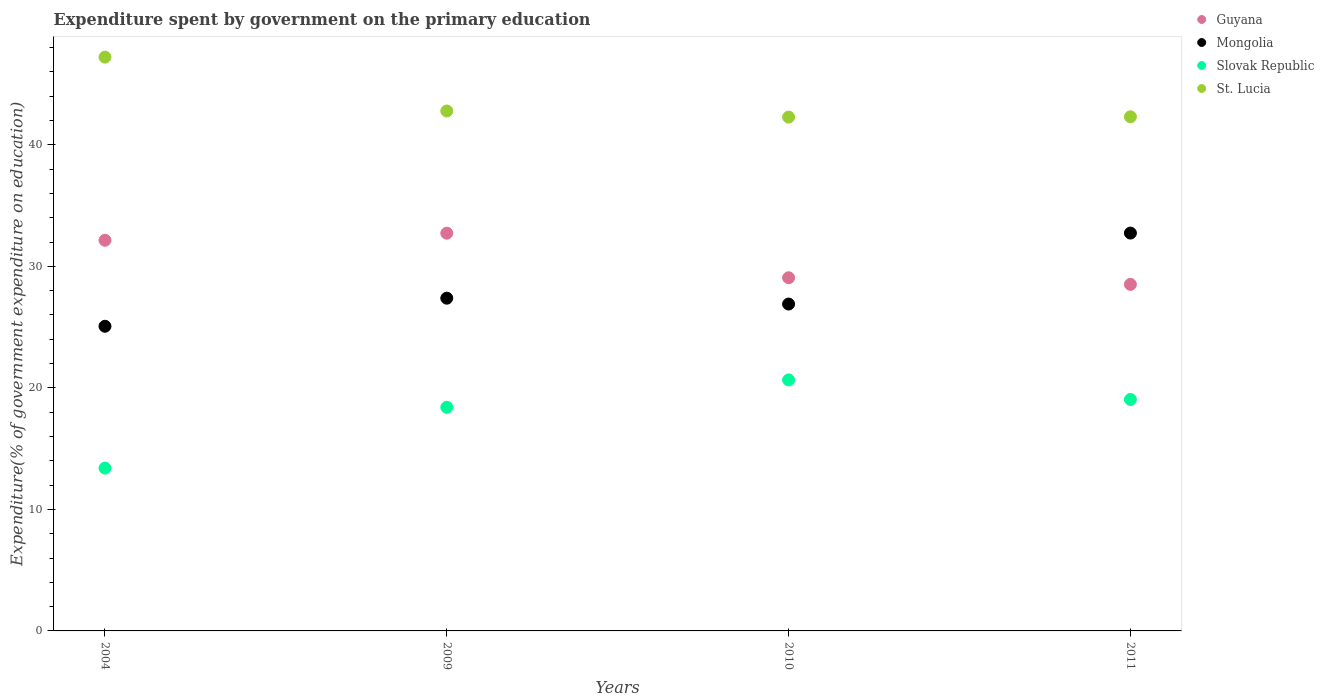How many different coloured dotlines are there?
Your answer should be compact. 4. What is the expenditure spent by government on the primary education in Mongolia in 2004?
Keep it short and to the point. 25.07. Across all years, what is the maximum expenditure spent by government on the primary education in Mongolia?
Offer a very short reply. 32.74. Across all years, what is the minimum expenditure spent by government on the primary education in Slovak Republic?
Provide a succinct answer. 13.4. In which year was the expenditure spent by government on the primary education in St. Lucia maximum?
Make the answer very short. 2004. What is the total expenditure spent by government on the primary education in Slovak Republic in the graph?
Your response must be concise. 71.5. What is the difference between the expenditure spent by government on the primary education in Mongolia in 2009 and that in 2011?
Ensure brevity in your answer.  -5.36. What is the difference between the expenditure spent by government on the primary education in Slovak Republic in 2004 and the expenditure spent by government on the primary education in St. Lucia in 2010?
Give a very brief answer. -28.88. What is the average expenditure spent by government on the primary education in Guyana per year?
Provide a short and direct response. 30.61. In the year 2009, what is the difference between the expenditure spent by government on the primary education in Guyana and expenditure spent by government on the primary education in Slovak Republic?
Offer a very short reply. 14.33. In how many years, is the expenditure spent by government on the primary education in St. Lucia greater than 16 %?
Your answer should be compact. 4. What is the ratio of the expenditure spent by government on the primary education in Mongolia in 2009 to that in 2011?
Make the answer very short. 0.84. Is the expenditure spent by government on the primary education in St. Lucia in 2009 less than that in 2010?
Provide a succinct answer. No. What is the difference between the highest and the second highest expenditure spent by government on the primary education in Slovak Republic?
Ensure brevity in your answer.  1.61. What is the difference between the highest and the lowest expenditure spent by government on the primary education in Mongolia?
Keep it short and to the point. 7.67. Is the sum of the expenditure spent by government on the primary education in St. Lucia in 2004 and 2010 greater than the maximum expenditure spent by government on the primary education in Mongolia across all years?
Offer a very short reply. Yes. Is it the case that in every year, the sum of the expenditure spent by government on the primary education in Slovak Republic and expenditure spent by government on the primary education in Guyana  is greater than the sum of expenditure spent by government on the primary education in St. Lucia and expenditure spent by government on the primary education in Mongolia?
Your response must be concise. Yes. How many dotlines are there?
Give a very brief answer. 4. Does the graph contain grids?
Ensure brevity in your answer.  No. Where does the legend appear in the graph?
Give a very brief answer. Top right. How are the legend labels stacked?
Give a very brief answer. Vertical. What is the title of the graph?
Ensure brevity in your answer.  Expenditure spent by government on the primary education. What is the label or title of the Y-axis?
Ensure brevity in your answer.  Expenditure(% of government expenditure on education). What is the Expenditure(% of government expenditure on education) of Guyana in 2004?
Give a very brief answer. 32.14. What is the Expenditure(% of government expenditure on education) of Mongolia in 2004?
Your answer should be compact. 25.07. What is the Expenditure(% of government expenditure on education) of Slovak Republic in 2004?
Your response must be concise. 13.4. What is the Expenditure(% of government expenditure on education) of St. Lucia in 2004?
Your answer should be compact. 47.21. What is the Expenditure(% of government expenditure on education) of Guyana in 2009?
Make the answer very short. 32.73. What is the Expenditure(% of government expenditure on education) in Mongolia in 2009?
Your response must be concise. 27.38. What is the Expenditure(% of government expenditure on education) of Slovak Republic in 2009?
Provide a short and direct response. 18.4. What is the Expenditure(% of government expenditure on education) of St. Lucia in 2009?
Your answer should be very brief. 42.78. What is the Expenditure(% of government expenditure on education) in Guyana in 2010?
Ensure brevity in your answer.  29.06. What is the Expenditure(% of government expenditure on education) in Mongolia in 2010?
Provide a short and direct response. 26.9. What is the Expenditure(% of government expenditure on education) in Slovak Republic in 2010?
Your answer should be very brief. 20.65. What is the Expenditure(% of government expenditure on education) of St. Lucia in 2010?
Make the answer very short. 42.28. What is the Expenditure(% of government expenditure on education) of Guyana in 2011?
Keep it short and to the point. 28.51. What is the Expenditure(% of government expenditure on education) of Mongolia in 2011?
Your answer should be compact. 32.74. What is the Expenditure(% of government expenditure on education) in Slovak Republic in 2011?
Provide a succinct answer. 19.05. What is the Expenditure(% of government expenditure on education) in St. Lucia in 2011?
Your answer should be very brief. 42.3. Across all years, what is the maximum Expenditure(% of government expenditure on education) in Guyana?
Ensure brevity in your answer.  32.73. Across all years, what is the maximum Expenditure(% of government expenditure on education) of Mongolia?
Provide a succinct answer. 32.74. Across all years, what is the maximum Expenditure(% of government expenditure on education) of Slovak Republic?
Your answer should be very brief. 20.65. Across all years, what is the maximum Expenditure(% of government expenditure on education) in St. Lucia?
Provide a succinct answer. 47.21. Across all years, what is the minimum Expenditure(% of government expenditure on education) of Guyana?
Your answer should be compact. 28.51. Across all years, what is the minimum Expenditure(% of government expenditure on education) of Mongolia?
Make the answer very short. 25.07. Across all years, what is the minimum Expenditure(% of government expenditure on education) of Slovak Republic?
Your answer should be very brief. 13.4. Across all years, what is the minimum Expenditure(% of government expenditure on education) of St. Lucia?
Offer a terse response. 42.28. What is the total Expenditure(% of government expenditure on education) in Guyana in the graph?
Offer a very short reply. 122.45. What is the total Expenditure(% of government expenditure on education) of Mongolia in the graph?
Make the answer very short. 112.08. What is the total Expenditure(% of government expenditure on education) in Slovak Republic in the graph?
Provide a short and direct response. 71.5. What is the total Expenditure(% of government expenditure on education) in St. Lucia in the graph?
Your response must be concise. 174.58. What is the difference between the Expenditure(% of government expenditure on education) of Guyana in 2004 and that in 2009?
Keep it short and to the point. -0.58. What is the difference between the Expenditure(% of government expenditure on education) in Mongolia in 2004 and that in 2009?
Your response must be concise. -2.31. What is the difference between the Expenditure(% of government expenditure on education) of Slovak Republic in 2004 and that in 2009?
Your response must be concise. -5. What is the difference between the Expenditure(% of government expenditure on education) of St. Lucia in 2004 and that in 2009?
Ensure brevity in your answer.  4.43. What is the difference between the Expenditure(% of government expenditure on education) in Guyana in 2004 and that in 2010?
Give a very brief answer. 3.08. What is the difference between the Expenditure(% of government expenditure on education) in Mongolia in 2004 and that in 2010?
Ensure brevity in your answer.  -1.83. What is the difference between the Expenditure(% of government expenditure on education) of Slovak Republic in 2004 and that in 2010?
Give a very brief answer. -7.26. What is the difference between the Expenditure(% of government expenditure on education) of St. Lucia in 2004 and that in 2010?
Your answer should be very brief. 4.93. What is the difference between the Expenditure(% of government expenditure on education) in Guyana in 2004 and that in 2011?
Make the answer very short. 3.63. What is the difference between the Expenditure(% of government expenditure on education) in Mongolia in 2004 and that in 2011?
Ensure brevity in your answer.  -7.67. What is the difference between the Expenditure(% of government expenditure on education) in Slovak Republic in 2004 and that in 2011?
Provide a short and direct response. -5.65. What is the difference between the Expenditure(% of government expenditure on education) of St. Lucia in 2004 and that in 2011?
Keep it short and to the point. 4.91. What is the difference between the Expenditure(% of government expenditure on education) in Guyana in 2009 and that in 2010?
Offer a very short reply. 3.67. What is the difference between the Expenditure(% of government expenditure on education) of Mongolia in 2009 and that in 2010?
Provide a succinct answer. 0.48. What is the difference between the Expenditure(% of government expenditure on education) in Slovak Republic in 2009 and that in 2010?
Your response must be concise. -2.25. What is the difference between the Expenditure(% of government expenditure on education) in St. Lucia in 2009 and that in 2010?
Offer a very short reply. 0.5. What is the difference between the Expenditure(% of government expenditure on education) in Guyana in 2009 and that in 2011?
Provide a succinct answer. 4.21. What is the difference between the Expenditure(% of government expenditure on education) in Mongolia in 2009 and that in 2011?
Make the answer very short. -5.36. What is the difference between the Expenditure(% of government expenditure on education) in Slovak Republic in 2009 and that in 2011?
Offer a very short reply. -0.65. What is the difference between the Expenditure(% of government expenditure on education) of St. Lucia in 2009 and that in 2011?
Offer a very short reply. 0.48. What is the difference between the Expenditure(% of government expenditure on education) in Guyana in 2010 and that in 2011?
Your response must be concise. 0.55. What is the difference between the Expenditure(% of government expenditure on education) of Mongolia in 2010 and that in 2011?
Make the answer very short. -5.84. What is the difference between the Expenditure(% of government expenditure on education) in Slovak Republic in 2010 and that in 2011?
Make the answer very short. 1.61. What is the difference between the Expenditure(% of government expenditure on education) of St. Lucia in 2010 and that in 2011?
Your answer should be very brief. -0.03. What is the difference between the Expenditure(% of government expenditure on education) of Guyana in 2004 and the Expenditure(% of government expenditure on education) of Mongolia in 2009?
Make the answer very short. 4.76. What is the difference between the Expenditure(% of government expenditure on education) of Guyana in 2004 and the Expenditure(% of government expenditure on education) of Slovak Republic in 2009?
Offer a terse response. 13.74. What is the difference between the Expenditure(% of government expenditure on education) of Guyana in 2004 and the Expenditure(% of government expenditure on education) of St. Lucia in 2009?
Your response must be concise. -10.64. What is the difference between the Expenditure(% of government expenditure on education) in Mongolia in 2004 and the Expenditure(% of government expenditure on education) in Slovak Republic in 2009?
Your answer should be compact. 6.67. What is the difference between the Expenditure(% of government expenditure on education) in Mongolia in 2004 and the Expenditure(% of government expenditure on education) in St. Lucia in 2009?
Keep it short and to the point. -17.71. What is the difference between the Expenditure(% of government expenditure on education) in Slovak Republic in 2004 and the Expenditure(% of government expenditure on education) in St. Lucia in 2009?
Your response must be concise. -29.39. What is the difference between the Expenditure(% of government expenditure on education) of Guyana in 2004 and the Expenditure(% of government expenditure on education) of Mongolia in 2010?
Offer a very short reply. 5.25. What is the difference between the Expenditure(% of government expenditure on education) of Guyana in 2004 and the Expenditure(% of government expenditure on education) of Slovak Republic in 2010?
Give a very brief answer. 11.49. What is the difference between the Expenditure(% of government expenditure on education) in Guyana in 2004 and the Expenditure(% of government expenditure on education) in St. Lucia in 2010?
Provide a succinct answer. -10.14. What is the difference between the Expenditure(% of government expenditure on education) of Mongolia in 2004 and the Expenditure(% of government expenditure on education) of Slovak Republic in 2010?
Your answer should be very brief. 4.41. What is the difference between the Expenditure(% of government expenditure on education) of Mongolia in 2004 and the Expenditure(% of government expenditure on education) of St. Lucia in 2010?
Offer a very short reply. -17.21. What is the difference between the Expenditure(% of government expenditure on education) of Slovak Republic in 2004 and the Expenditure(% of government expenditure on education) of St. Lucia in 2010?
Offer a terse response. -28.88. What is the difference between the Expenditure(% of government expenditure on education) in Guyana in 2004 and the Expenditure(% of government expenditure on education) in Mongolia in 2011?
Ensure brevity in your answer.  -0.59. What is the difference between the Expenditure(% of government expenditure on education) in Guyana in 2004 and the Expenditure(% of government expenditure on education) in Slovak Republic in 2011?
Make the answer very short. 13.1. What is the difference between the Expenditure(% of government expenditure on education) of Guyana in 2004 and the Expenditure(% of government expenditure on education) of St. Lucia in 2011?
Your answer should be compact. -10.16. What is the difference between the Expenditure(% of government expenditure on education) of Mongolia in 2004 and the Expenditure(% of government expenditure on education) of Slovak Republic in 2011?
Offer a terse response. 6.02. What is the difference between the Expenditure(% of government expenditure on education) of Mongolia in 2004 and the Expenditure(% of government expenditure on education) of St. Lucia in 2011?
Offer a terse response. -17.24. What is the difference between the Expenditure(% of government expenditure on education) of Slovak Republic in 2004 and the Expenditure(% of government expenditure on education) of St. Lucia in 2011?
Provide a succinct answer. -28.91. What is the difference between the Expenditure(% of government expenditure on education) of Guyana in 2009 and the Expenditure(% of government expenditure on education) of Mongolia in 2010?
Your response must be concise. 5.83. What is the difference between the Expenditure(% of government expenditure on education) of Guyana in 2009 and the Expenditure(% of government expenditure on education) of Slovak Republic in 2010?
Provide a short and direct response. 12.07. What is the difference between the Expenditure(% of government expenditure on education) of Guyana in 2009 and the Expenditure(% of government expenditure on education) of St. Lucia in 2010?
Give a very brief answer. -9.55. What is the difference between the Expenditure(% of government expenditure on education) in Mongolia in 2009 and the Expenditure(% of government expenditure on education) in Slovak Republic in 2010?
Ensure brevity in your answer.  6.73. What is the difference between the Expenditure(% of government expenditure on education) of Mongolia in 2009 and the Expenditure(% of government expenditure on education) of St. Lucia in 2010?
Make the answer very short. -14.9. What is the difference between the Expenditure(% of government expenditure on education) of Slovak Republic in 2009 and the Expenditure(% of government expenditure on education) of St. Lucia in 2010?
Provide a short and direct response. -23.88. What is the difference between the Expenditure(% of government expenditure on education) in Guyana in 2009 and the Expenditure(% of government expenditure on education) in Mongolia in 2011?
Make the answer very short. -0.01. What is the difference between the Expenditure(% of government expenditure on education) of Guyana in 2009 and the Expenditure(% of government expenditure on education) of Slovak Republic in 2011?
Your answer should be very brief. 13.68. What is the difference between the Expenditure(% of government expenditure on education) in Guyana in 2009 and the Expenditure(% of government expenditure on education) in St. Lucia in 2011?
Give a very brief answer. -9.58. What is the difference between the Expenditure(% of government expenditure on education) of Mongolia in 2009 and the Expenditure(% of government expenditure on education) of Slovak Republic in 2011?
Make the answer very short. 8.33. What is the difference between the Expenditure(% of government expenditure on education) of Mongolia in 2009 and the Expenditure(% of government expenditure on education) of St. Lucia in 2011?
Offer a very short reply. -14.93. What is the difference between the Expenditure(% of government expenditure on education) of Slovak Republic in 2009 and the Expenditure(% of government expenditure on education) of St. Lucia in 2011?
Make the answer very short. -23.9. What is the difference between the Expenditure(% of government expenditure on education) of Guyana in 2010 and the Expenditure(% of government expenditure on education) of Mongolia in 2011?
Ensure brevity in your answer.  -3.68. What is the difference between the Expenditure(% of government expenditure on education) in Guyana in 2010 and the Expenditure(% of government expenditure on education) in Slovak Republic in 2011?
Your response must be concise. 10.01. What is the difference between the Expenditure(% of government expenditure on education) in Guyana in 2010 and the Expenditure(% of government expenditure on education) in St. Lucia in 2011?
Offer a terse response. -13.24. What is the difference between the Expenditure(% of government expenditure on education) in Mongolia in 2010 and the Expenditure(% of government expenditure on education) in Slovak Republic in 2011?
Keep it short and to the point. 7.85. What is the difference between the Expenditure(% of government expenditure on education) of Mongolia in 2010 and the Expenditure(% of government expenditure on education) of St. Lucia in 2011?
Give a very brief answer. -15.41. What is the difference between the Expenditure(% of government expenditure on education) of Slovak Republic in 2010 and the Expenditure(% of government expenditure on education) of St. Lucia in 2011?
Offer a terse response. -21.65. What is the average Expenditure(% of government expenditure on education) in Guyana per year?
Give a very brief answer. 30.61. What is the average Expenditure(% of government expenditure on education) in Mongolia per year?
Your response must be concise. 28.02. What is the average Expenditure(% of government expenditure on education) of Slovak Republic per year?
Make the answer very short. 17.87. What is the average Expenditure(% of government expenditure on education) in St. Lucia per year?
Provide a short and direct response. 43.65. In the year 2004, what is the difference between the Expenditure(% of government expenditure on education) of Guyana and Expenditure(% of government expenditure on education) of Mongolia?
Offer a terse response. 7.08. In the year 2004, what is the difference between the Expenditure(% of government expenditure on education) in Guyana and Expenditure(% of government expenditure on education) in Slovak Republic?
Your response must be concise. 18.75. In the year 2004, what is the difference between the Expenditure(% of government expenditure on education) in Guyana and Expenditure(% of government expenditure on education) in St. Lucia?
Your response must be concise. -15.07. In the year 2004, what is the difference between the Expenditure(% of government expenditure on education) of Mongolia and Expenditure(% of government expenditure on education) of Slovak Republic?
Give a very brief answer. 11.67. In the year 2004, what is the difference between the Expenditure(% of government expenditure on education) of Mongolia and Expenditure(% of government expenditure on education) of St. Lucia?
Give a very brief answer. -22.15. In the year 2004, what is the difference between the Expenditure(% of government expenditure on education) of Slovak Republic and Expenditure(% of government expenditure on education) of St. Lucia?
Make the answer very short. -33.82. In the year 2009, what is the difference between the Expenditure(% of government expenditure on education) in Guyana and Expenditure(% of government expenditure on education) in Mongolia?
Ensure brevity in your answer.  5.35. In the year 2009, what is the difference between the Expenditure(% of government expenditure on education) of Guyana and Expenditure(% of government expenditure on education) of Slovak Republic?
Offer a very short reply. 14.33. In the year 2009, what is the difference between the Expenditure(% of government expenditure on education) of Guyana and Expenditure(% of government expenditure on education) of St. Lucia?
Offer a terse response. -10.06. In the year 2009, what is the difference between the Expenditure(% of government expenditure on education) of Mongolia and Expenditure(% of government expenditure on education) of Slovak Republic?
Your answer should be compact. 8.98. In the year 2009, what is the difference between the Expenditure(% of government expenditure on education) of Mongolia and Expenditure(% of government expenditure on education) of St. Lucia?
Provide a succinct answer. -15.4. In the year 2009, what is the difference between the Expenditure(% of government expenditure on education) of Slovak Republic and Expenditure(% of government expenditure on education) of St. Lucia?
Provide a succinct answer. -24.38. In the year 2010, what is the difference between the Expenditure(% of government expenditure on education) of Guyana and Expenditure(% of government expenditure on education) of Mongolia?
Provide a succinct answer. 2.16. In the year 2010, what is the difference between the Expenditure(% of government expenditure on education) of Guyana and Expenditure(% of government expenditure on education) of Slovak Republic?
Offer a terse response. 8.41. In the year 2010, what is the difference between the Expenditure(% of government expenditure on education) in Guyana and Expenditure(% of government expenditure on education) in St. Lucia?
Your answer should be very brief. -13.22. In the year 2010, what is the difference between the Expenditure(% of government expenditure on education) of Mongolia and Expenditure(% of government expenditure on education) of Slovak Republic?
Provide a short and direct response. 6.24. In the year 2010, what is the difference between the Expenditure(% of government expenditure on education) of Mongolia and Expenditure(% of government expenditure on education) of St. Lucia?
Provide a succinct answer. -15.38. In the year 2010, what is the difference between the Expenditure(% of government expenditure on education) in Slovak Republic and Expenditure(% of government expenditure on education) in St. Lucia?
Provide a short and direct response. -21.63. In the year 2011, what is the difference between the Expenditure(% of government expenditure on education) of Guyana and Expenditure(% of government expenditure on education) of Mongolia?
Ensure brevity in your answer.  -4.22. In the year 2011, what is the difference between the Expenditure(% of government expenditure on education) of Guyana and Expenditure(% of government expenditure on education) of Slovak Republic?
Provide a short and direct response. 9.47. In the year 2011, what is the difference between the Expenditure(% of government expenditure on education) in Guyana and Expenditure(% of government expenditure on education) in St. Lucia?
Offer a very short reply. -13.79. In the year 2011, what is the difference between the Expenditure(% of government expenditure on education) in Mongolia and Expenditure(% of government expenditure on education) in Slovak Republic?
Give a very brief answer. 13.69. In the year 2011, what is the difference between the Expenditure(% of government expenditure on education) of Mongolia and Expenditure(% of government expenditure on education) of St. Lucia?
Provide a succinct answer. -9.57. In the year 2011, what is the difference between the Expenditure(% of government expenditure on education) in Slovak Republic and Expenditure(% of government expenditure on education) in St. Lucia?
Ensure brevity in your answer.  -23.26. What is the ratio of the Expenditure(% of government expenditure on education) of Guyana in 2004 to that in 2009?
Make the answer very short. 0.98. What is the ratio of the Expenditure(% of government expenditure on education) of Mongolia in 2004 to that in 2009?
Make the answer very short. 0.92. What is the ratio of the Expenditure(% of government expenditure on education) in Slovak Republic in 2004 to that in 2009?
Your response must be concise. 0.73. What is the ratio of the Expenditure(% of government expenditure on education) of St. Lucia in 2004 to that in 2009?
Provide a succinct answer. 1.1. What is the ratio of the Expenditure(% of government expenditure on education) in Guyana in 2004 to that in 2010?
Your response must be concise. 1.11. What is the ratio of the Expenditure(% of government expenditure on education) in Mongolia in 2004 to that in 2010?
Make the answer very short. 0.93. What is the ratio of the Expenditure(% of government expenditure on education) of Slovak Republic in 2004 to that in 2010?
Provide a short and direct response. 0.65. What is the ratio of the Expenditure(% of government expenditure on education) in St. Lucia in 2004 to that in 2010?
Offer a very short reply. 1.12. What is the ratio of the Expenditure(% of government expenditure on education) in Guyana in 2004 to that in 2011?
Your answer should be compact. 1.13. What is the ratio of the Expenditure(% of government expenditure on education) of Mongolia in 2004 to that in 2011?
Give a very brief answer. 0.77. What is the ratio of the Expenditure(% of government expenditure on education) of Slovak Republic in 2004 to that in 2011?
Your answer should be very brief. 0.7. What is the ratio of the Expenditure(% of government expenditure on education) in St. Lucia in 2004 to that in 2011?
Your response must be concise. 1.12. What is the ratio of the Expenditure(% of government expenditure on education) of Guyana in 2009 to that in 2010?
Your answer should be very brief. 1.13. What is the ratio of the Expenditure(% of government expenditure on education) in Slovak Republic in 2009 to that in 2010?
Offer a terse response. 0.89. What is the ratio of the Expenditure(% of government expenditure on education) of St. Lucia in 2009 to that in 2010?
Offer a very short reply. 1.01. What is the ratio of the Expenditure(% of government expenditure on education) of Guyana in 2009 to that in 2011?
Your answer should be compact. 1.15. What is the ratio of the Expenditure(% of government expenditure on education) of Mongolia in 2009 to that in 2011?
Provide a short and direct response. 0.84. What is the ratio of the Expenditure(% of government expenditure on education) of Slovak Republic in 2009 to that in 2011?
Your answer should be compact. 0.97. What is the ratio of the Expenditure(% of government expenditure on education) in St. Lucia in 2009 to that in 2011?
Offer a terse response. 1.01. What is the ratio of the Expenditure(% of government expenditure on education) in Guyana in 2010 to that in 2011?
Offer a terse response. 1.02. What is the ratio of the Expenditure(% of government expenditure on education) in Mongolia in 2010 to that in 2011?
Keep it short and to the point. 0.82. What is the ratio of the Expenditure(% of government expenditure on education) in Slovak Republic in 2010 to that in 2011?
Keep it short and to the point. 1.08. What is the ratio of the Expenditure(% of government expenditure on education) in St. Lucia in 2010 to that in 2011?
Keep it short and to the point. 1. What is the difference between the highest and the second highest Expenditure(% of government expenditure on education) in Guyana?
Keep it short and to the point. 0.58. What is the difference between the highest and the second highest Expenditure(% of government expenditure on education) in Mongolia?
Make the answer very short. 5.36. What is the difference between the highest and the second highest Expenditure(% of government expenditure on education) of Slovak Republic?
Provide a short and direct response. 1.61. What is the difference between the highest and the second highest Expenditure(% of government expenditure on education) of St. Lucia?
Ensure brevity in your answer.  4.43. What is the difference between the highest and the lowest Expenditure(% of government expenditure on education) of Guyana?
Offer a terse response. 4.21. What is the difference between the highest and the lowest Expenditure(% of government expenditure on education) of Mongolia?
Keep it short and to the point. 7.67. What is the difference between the highest and the lowest Expenditure(% of government expenditure on education) in Slovak Republic?
Offer a terse response. 7.26. What is the difference between the highest and the lowest Expenditure(% of government expenditure on education) of St. Lucia?
Your answer should be very brief. 4.93. 